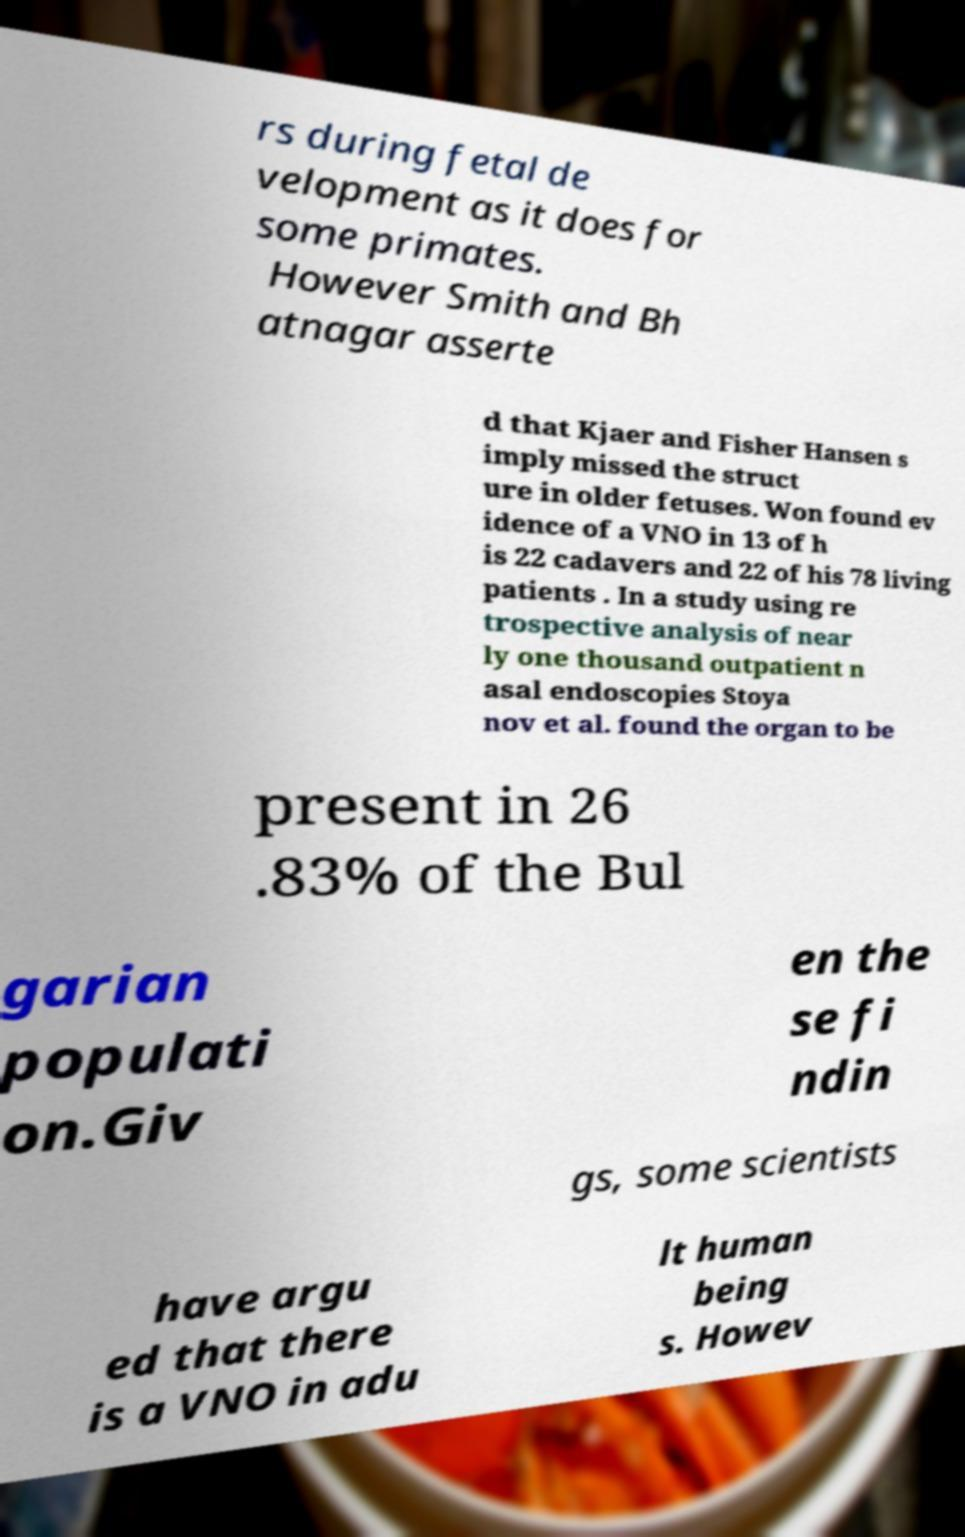Could you assist in decoding the text presented in this image and type it out clearly? rs during fetal de velopment as it does for some primates. However Smith and Bh atnagar asserte d that Kjaer and Fisher Hansen s imply missed the struct ure in older fetuses. Won found ev idence of a VNO in 13 of h is 22 cadavers and 22 of his 78 living patients . In a study using re trospective analysis of near ly one thousand outpatient n asal endoscopies Stoya nov et al. found the organ to be present in 26 .83% of the Bul garian populati on.Giv en the se fi ndin gs, some scientists have argu ed that there is a VNO in adu lt human being s. Howev 